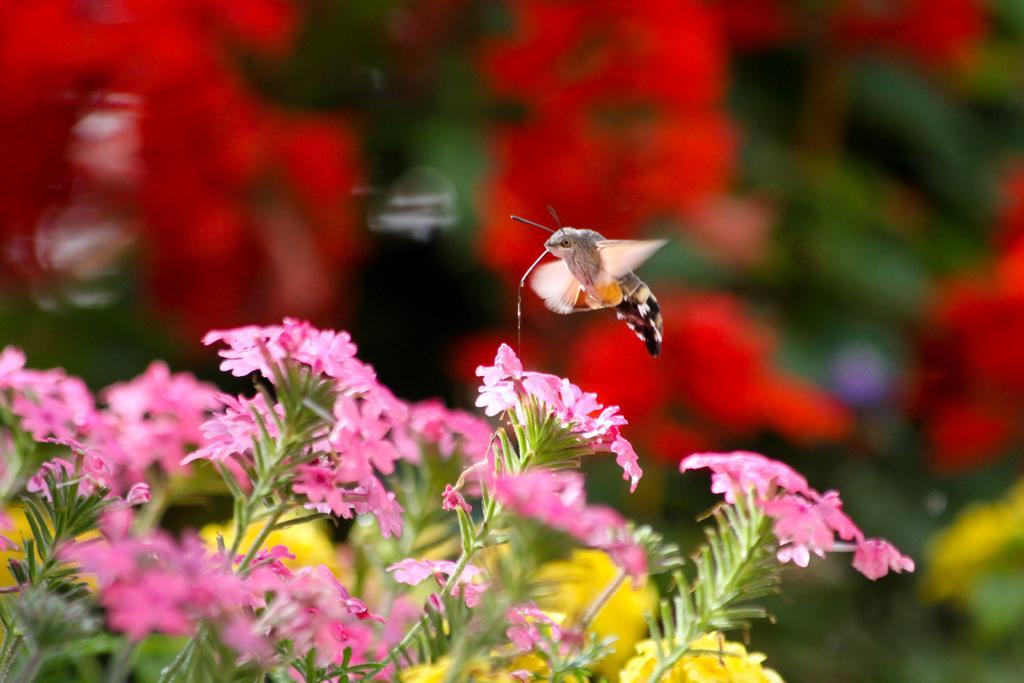Could you give a brief overview of what you see in this image? In this image I can see pink color flowers visible on plants and I can a butterfly visible on flowers. 